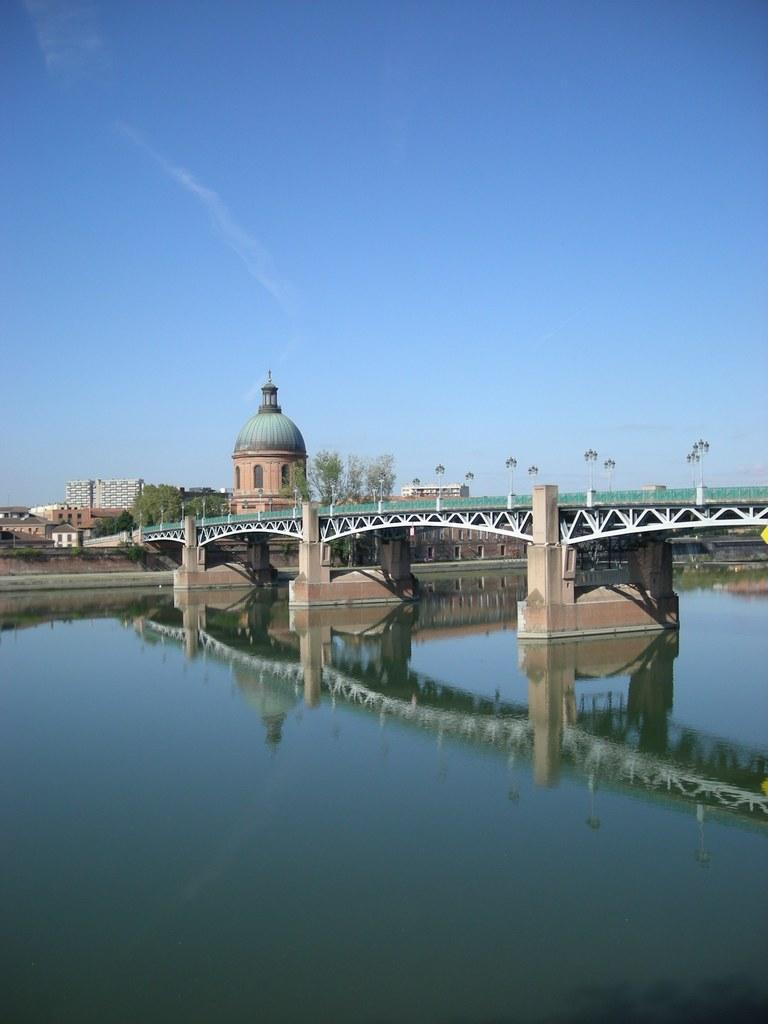What structure is present in the image? There is a bridge in the image. What is located beneath the bridge? There is water under the bridge. What can be seen in the background of the image? There are buildings, trees, and lights in the background of the image. What is visible at the top of the image? The sky is visible at the top of the image. How does the bridge express its dislike for the water below it in the image? The bridge does not express any emotions, as it is an inanimate object. 